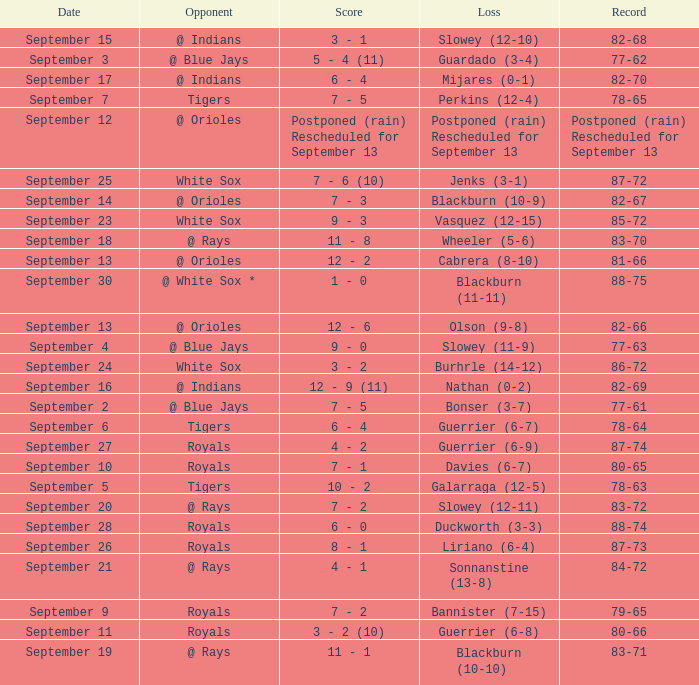What date has the record of 77-62? September 3. Parse the table in full. {'header': ['Date', 'Opponent', 'Score', 'Loss', 'Record'], 'rows': [['September 15', '@ Indians', '3 - 1', 'Slowey (12-10)', '82-68'], ['September 3', '@ Blue Jays', '5 - 4 (11)', 'Guardado (3-4)', '77-62'], ['September 17', '@ Indians', '6 - 4', 'Mijares (0-1)', '82-70'], ['September 7', 'Tigers', '7 - 5', 'Perkins (12-4)', '78-65'], ['September 12', '@ Orioles', 'Postponed (rain) Rescheduled for September 13', 'Postponed (rain) Rescheduled for September 13', 'Postponed (rain) Rescheduled for September 13'], ['September 25', 'White Sox', '7 - 6 (10)', 'Jenks (3-1)', '87-72'], ['September 14', '@ Orioles', '7 - 3', 'Blackburn (10-9)', '82-67'], ['September 23', 'White Sox', '9 - 3', 'Vasquez (12-15)', '85-72'], ['September 18', '@ Rays', '11 - 8', 'Wheeler (5-6)', '83-70'], ['September 13', '@ Orioles', '12 - 2', 'Cabrera (8-10)', '81-66'], ['September 30', '@ White Sox *', '1 - 0', 'Blackburn (11-11)', '88-75'], ['September 13', '@ Orioles', '12 - 6', 'Olson (9-8)', '82-66'], ['September 4', '@ Blue Jays', '9 - 0', 'Slowey (11-9)', '77-63'], ['September 24', 'White Sox', '3 - 2', 'Burhrle (14-12)', '86-72'], ['September 16', '@ Indians', '12 - 9 (11)', 'Nathan (0-2)', '82-69'], ['September 2', '@ Blue Jays', '7 - 5', 'Bonser (3-7)', '77-61'], ['September 6', 'Tigers', '6 - 4', 'Guerrier (6-7)', '78-64'], ['September 27', 'Royals', '4 - 2', 'Guerrier (6-9)', '87-74'], ['September 10', 'Royals', '7 - 1', 'Davies (6-7)', '80-65'], ['September 5', 'Tigers', '10 - 2', 'Galarraga (12-5)', '78-63'], ['September 20', '@ Rays', '7 - 2', 'Slowey (12-11)', '83-72'], ['September 28', 'Royals', '6 - 0', 'Duckworth (3-3)', '88-74'], ['September 26', 'Royals', '8 - 1', 'Liriano (6-4)', '87-73'], ['September 21', '@ Rays', '4 - 1', 'Sonnanstine (13-8)', '84-72'], ['September 9', 'Royals', '7 - 2', 'Bannister (7-15)', '79-65'], ['September 11', 'Royals', '3 - 2 (10)', 'Guerrier (6-8)', '80-66'], ['September 19', '@ Rays', '11 - 1', 'Blackburn (10-10)', '83-71']]} 